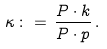Convert formula to latex. <formula><loc_0><loc_0><loc_500><loc_500>\kappa \, \colon = \, \frac { P \cdot k } { P \cdot p } \, .</formula> 